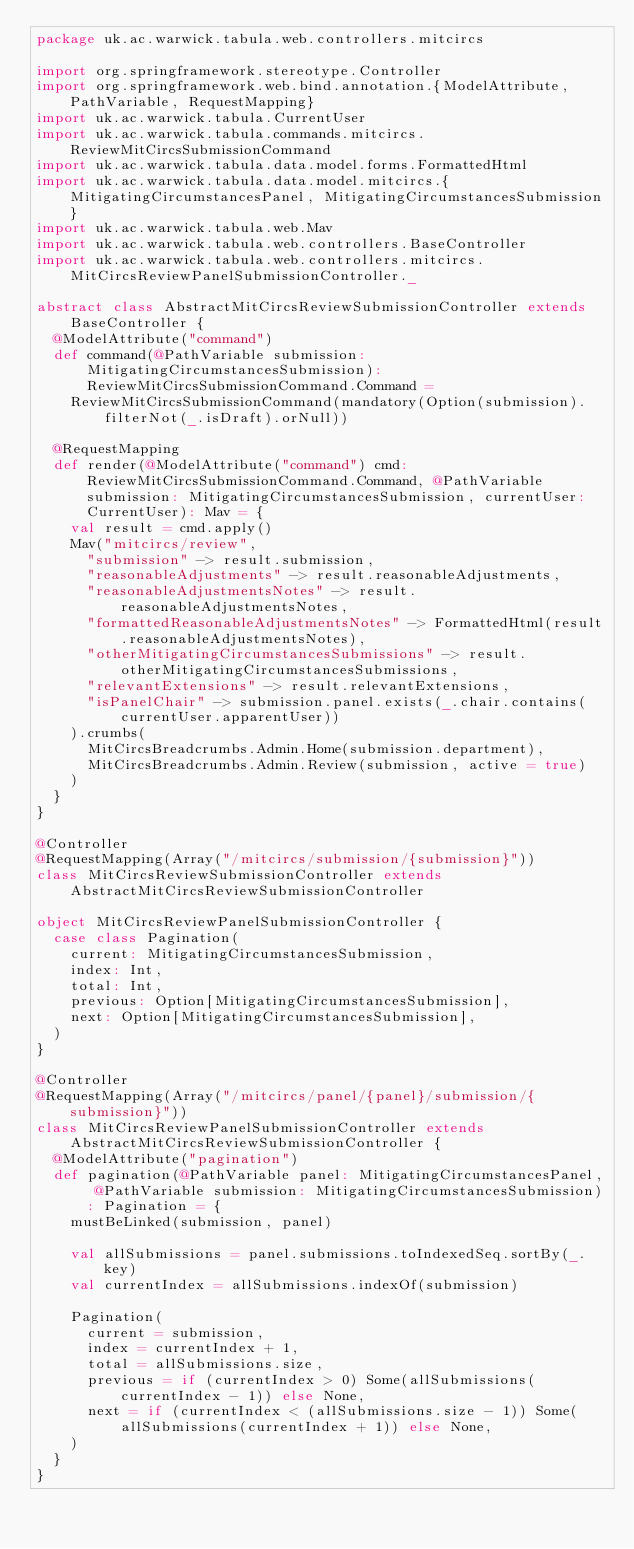<code> <loc_0><loc_0><loc_500><loc_500><_Scala_>package uk.ac.warwick.tabula.web.controllers.mitcircs

import org.springframework.stereotype.Controller
import org.springframework.web.bind.annotation.{ModelAttribute, PathVariable, RequestMapping}
import uk.ac.warwick.tabula.CurrentUser
import uk.ac.warwick.tabula.commands.mitcircs.ReviewMitCircsSubmissionCommand
import uk.ac.warwick.tabula.data.model.forms.FormattedHtml
import uk.ac.warwick.tabula.data.model.mitcircs.{MitigatingCircumstancesPanel, MitigatingCircumstancesSubmission}
import uk.ac.warwick.tabula.web.Mav
import uk.ac.warwick.tabula.web.controllers.BaseController
import uk.ac.warwick.tabula.web.controllers.mitcircs.MitCircsReviewPanelSubmissionController._

abstract class AbstractMitCircsReviewSubmissionController extends BaseController {
  @ModelAttribute("command")
  def command(@PathVariable submission: MitigatingCircumstancesSubmission): ReviewMitCircsSubmissionCommand.Command =
    ReviewMitCircsSubmissionCommand(mandatory(Option(submission).filterNot(_.isDraft).orNull))

  @RequestMapping
  def render(@ModelAttribute("command") cmd: ReviewMitCircsSubmissionCommand.Command, @PathVariable submission: MitigatingCircumstancesSubmission, currentUser: CurrentUser): Mav = {
    val result = cmd.apply()
    Mav("mitcircs/review",
      "submission" -> result.submission,
      "reasonableAdjustments" -> result.reasonableAdjustments,
      "reasonableAdjustmentsNotes" -> result.reasonableAdjustmentsNotes,
      "formattedReasonableAdjustmentsNotes" -> FormattedHtml(result.reasonableAdjustmentsNotes),
      "otherMitigatingCircumstancesSubmissions" -> result.otherMitigatingCircumstancesSubmissions,
      "relevantExtensions" -> result.relevantExtensions,
      "isPanelChair" -> submission.panel.exists(_.chair.contains(currentUser.apparentUser))
    ).crumbs(
      MitCircsBreadcrumbs.Admin.Home(submission.department),
      MitCircsBreadcrumbs.Admin.Review(submission, active = true)
    )
  }
}

@Controller
@RequestMapping(Array("/mitcircs/submission/{submission}"))
class MitCircsReviewSubmissionController extends AbstractMitCircsReviewSubmissionController

object MitCircsReviewPanelSubmissionController {
  case class Pagination(
    current: MitigatingCircumstancesSubmission,
    index: Int,
    total: Int,
    previous: Option[MitigatingCircumstancesSubmission],
    next: Option[MitigatingCircumstancesSubmission],
  )
}

@Controller
@RequestMapping(Array("/mitcircs/panel/{panel}/submission/{submission}"))
class MitCircsReviewPanelSubmissionController extends AbstractMitCircsReviewSubmissionController {
  @ModelAttribute("pagination")
  def pagination(@PathVariable panel: MitigatingCircumstancesPanel, @PathVariable submission: MitigatingCircumstancesSubmission): Pagination = {
    mustBeLinked(submission, panel)

    val allSubmissions = panel.submissions.toIndexedSeq.sortBy(_.key)
    val currentIndex = allSubmissions.indexOf(submission)

    Pagination(
      current = submission,
      index = currentIndex + 1,
      total = allSubmissions.size,
      previous = if (currentIndex > 0) Some(allSubmissions(currentIndex - 1)) else None,
      next = if (currentIndex < (allSubmissions.size - 1)) Some(allSubmissions(currentIndex + 1)) else None,
    )
  }
}
</code> 